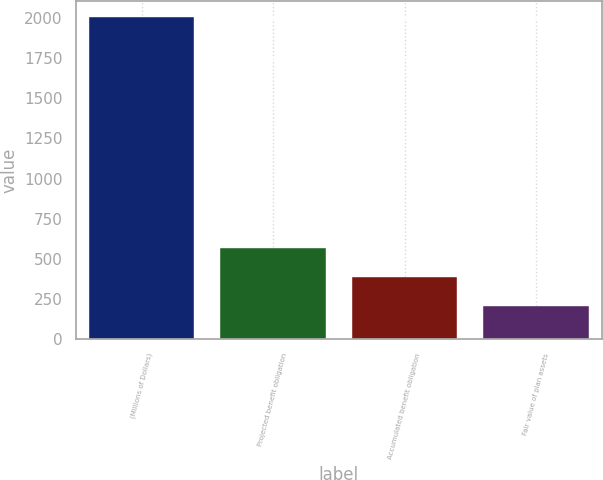Convert chart. <chart><loc_0><loc_0><loc_500><loc_500><bar_chart><fcel>(Millions of Dollars)<fcel>Projected benefit obligation<fcel>Accumulated benefit obligation<fcel>Fair value of plan assets<nl><fcel>2005<fcel>568.76<fcel>389.23<fcel>209.7<nl></chart> 